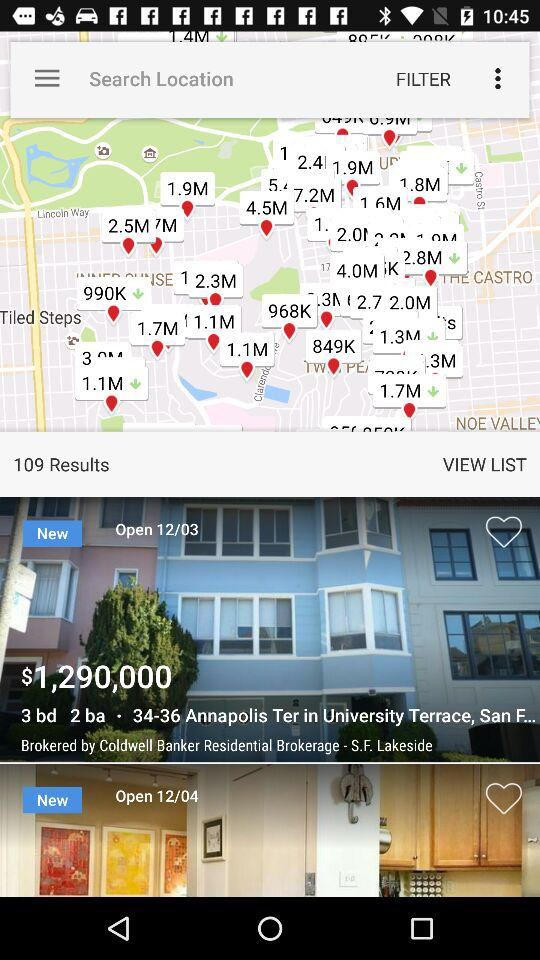What is the location mentioned? The mentioned location is 34-36 Annapolis Ter in University Terrace, San F.... 